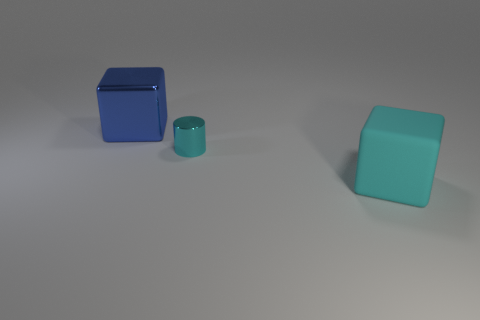What is the material of the other thing that is the same color as the rubber thing?
Ensure brevity in your answer.  Metal. The large cube behind the big object on the right side of the tiny cyan thing is made of what material?
Your response must be concise. Metal. There is a metal object that is on the right side of the large blue metallic cube; is its shape the same as the big cyan matte object?
Provide a succinct answer. No. What is the color of the large cube that is the same material as the tiny object?
Provide a short and direct response. Blue. What material is the large thing behind the cyan rubber thing?
Offer a terse response. Metal. There is a small cyan object; does it have the same shape as the metallic thing left of the cylinder?
Ensure brevity in your answer.  No. The thing that is both right of the metal cube and left of the big cyan rubber block is made of what material?
Offer a terse response. Metal. There is a shiny block that is the same size as the matte cube; what is its color?
Your answer should be very brief. Blue. Is the material of the big cyan cube the same as the cube that is behind the cyan cube?
Keep it short and to the point. No. How many other objects are the same size as the blue cube?
Offer a very short reply. 1. 